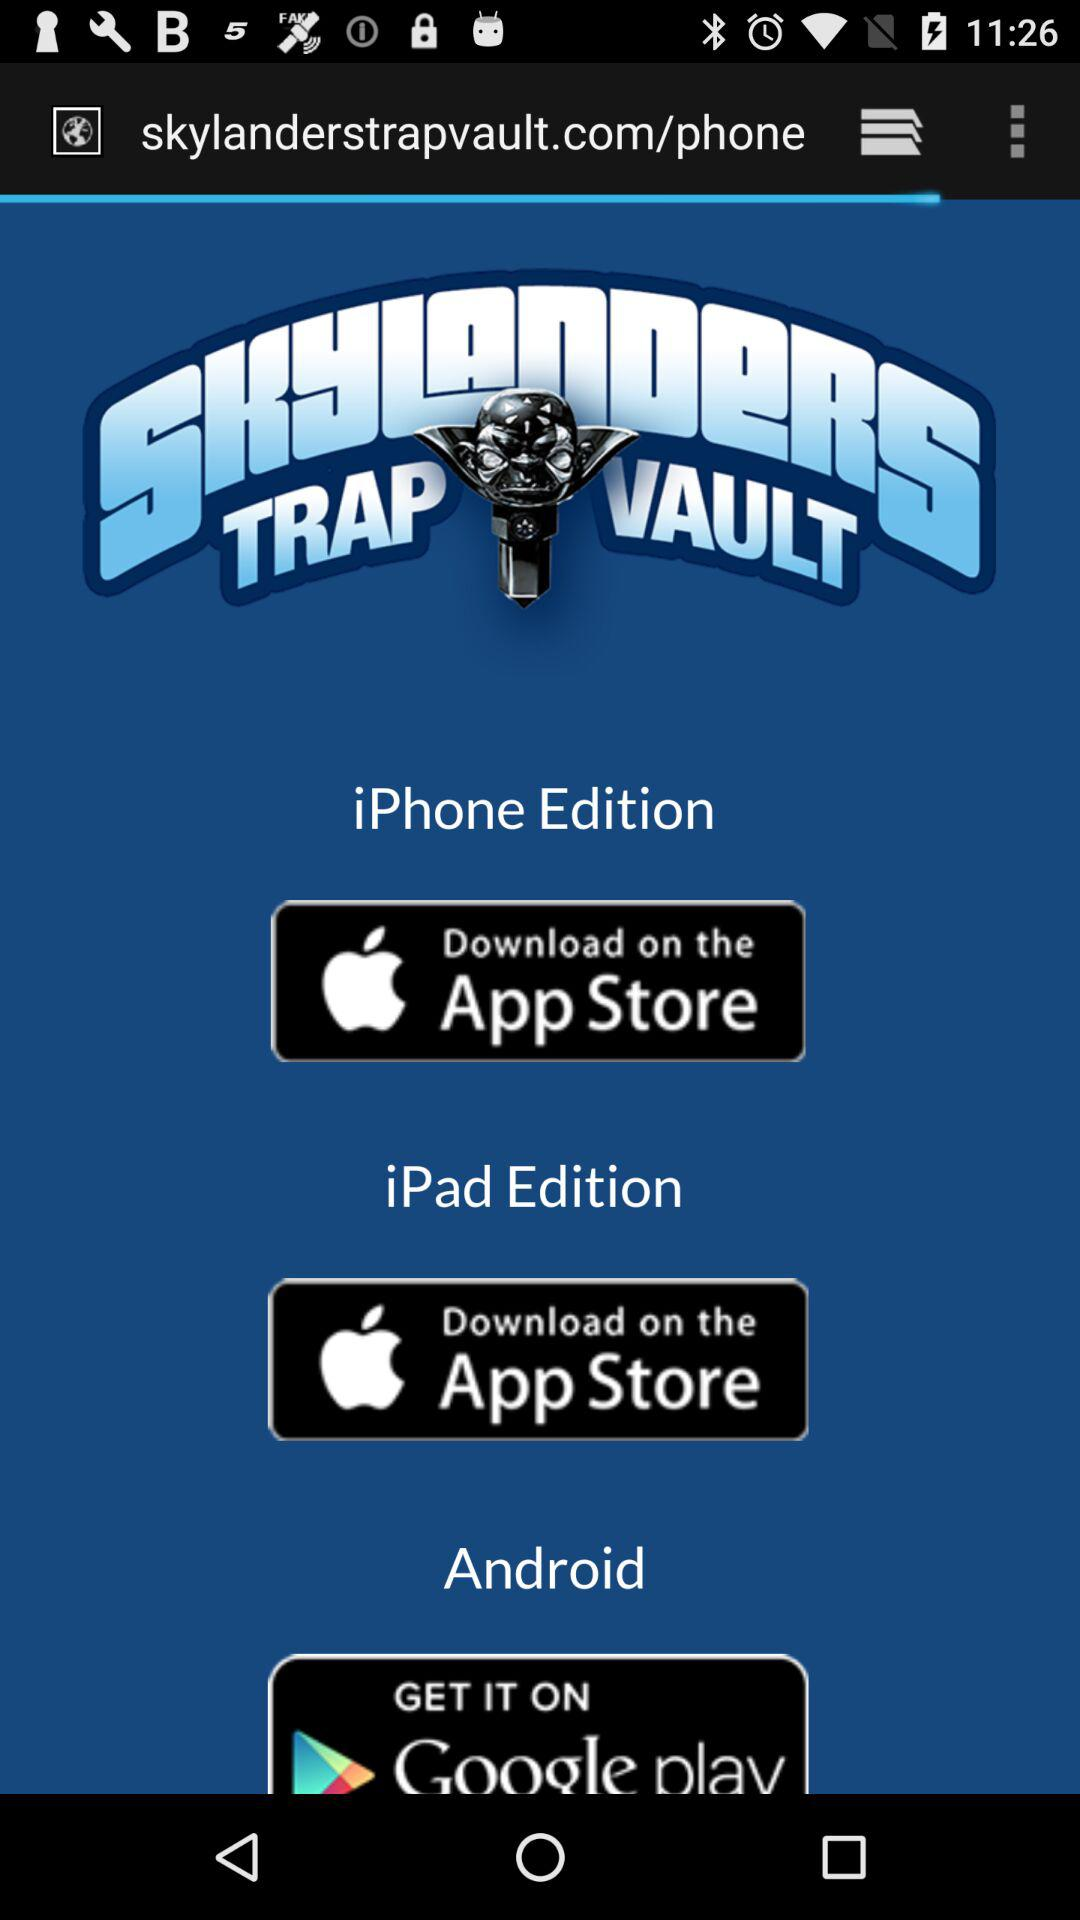How many download options are there for iPhone?
Answer the question using a single word or phrase. 2 